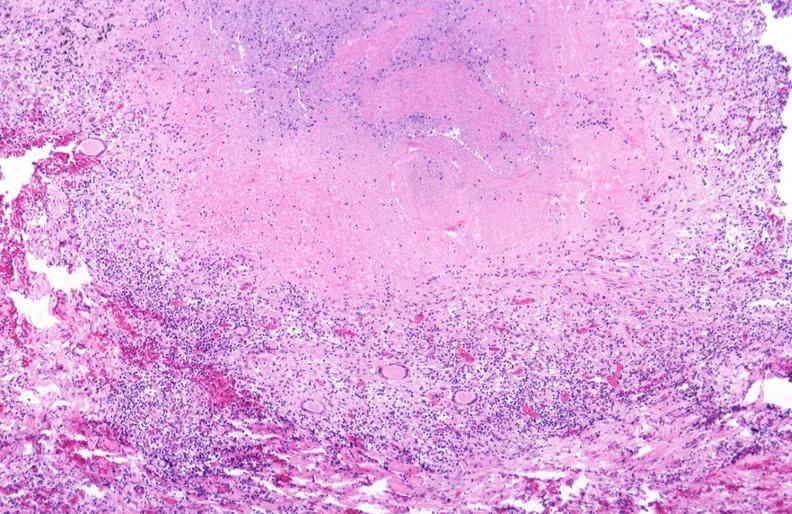what is present?
Answer the question using a single word or phrase. Respiratory 